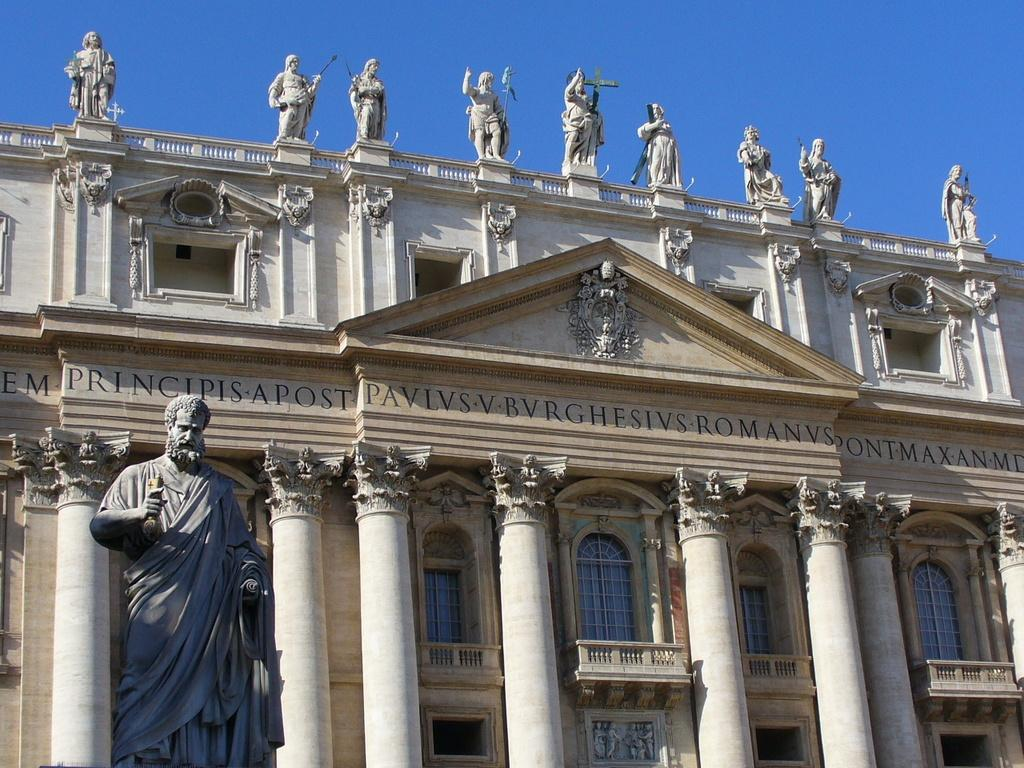What is the main subject in the image? There is a human statue standing in the image. What can be seen behind the human statue? There is a building behind the human statue. Are there any other human statues in the image? Yes, there are multiple human statues standing on the building. What is the condition of the sky in the image? The sky is clear in the image. What type of statement can be seen written on the human statue? There is no statement written on the human statue in the image. Can you describe the mist surrounding the human statues? There is no mist present in the image; the sky is clear. 